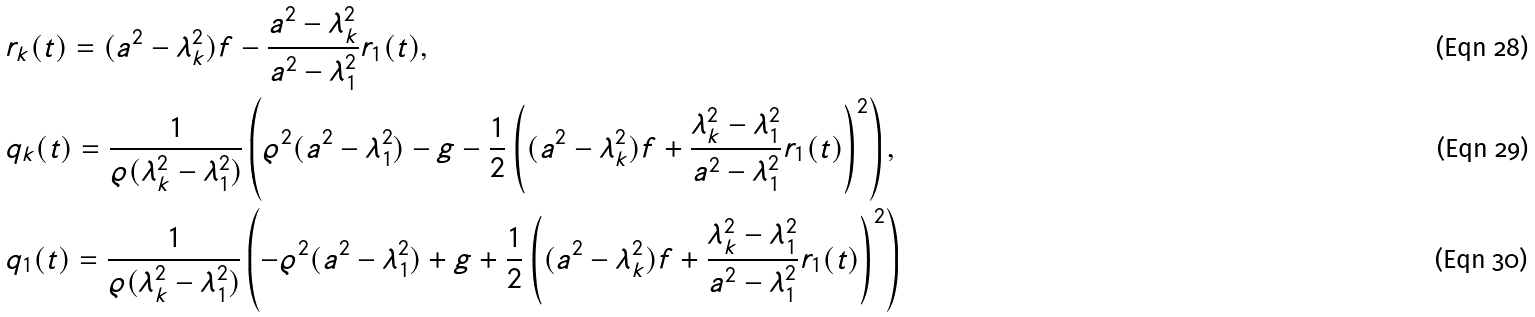Convert formula to latex. <formula><loc_0><loc_0><loc_500><loc_500>& r _ { k } ( t ) = ( a ^ { 2 } - \lambda _ { k } ^ { 2 } ) f - \frac { a ^ { 2 } - \lambda _ { k } ^ { 2 } } { a ^ { 2 } - \lambda _ { 1 } ^ { 2 } } r _ { 1 } ( t ) , \\ & q _ { k } ( t ) = \frac { 1 } { \varrho ( \lambda _ { k } ^ { 2 } - \lambda _ { 1 } ^ { 2 } ) } \left ( \varrho ^ { 2 } ( a ^ { 2 } - \lambda _ { 1 } ^ { 2 } ) - g - \frac { 1 } { 2 } \left ( ( a ^ { 2 } - \lambda _ { k } ^ { 2 } ) f + \frac { \lambda _ { k } ^ { 2 } - \lambda _ { 1 } ^ { 2 } } { a ^ { 2 } - \lambda _ { 1 } ^ { 2 } } r _ { 1 } ( t ) \right ) ^ { 2 } \right ) , \\ & q _ { 1 } ( t ) = \frac { 1 } { \varrho ( \lambda _ { k } ^ { 2 } - \lambda _ { 1 } ^ { 2 } ) } \left ( - \varrho ^ { 2 } ( a ^ { 2 } - \lambda _ { 1 } ^ { 2 } ) + g + \frac { 1 } { 2 } \left ( ( a ^ { 2 } - \lambda _ { k } ^ { 2 } ) f + \frac { \lambda _ { k } ^ { 2 } - \lambda _ { 1 } ^ { 2 } } { a ^ { 2 } - \lambda _ { 1 } ^ { 2 } } r _ { 1 } ( t ) \right ) ^ { 2 } \right )</formula> 